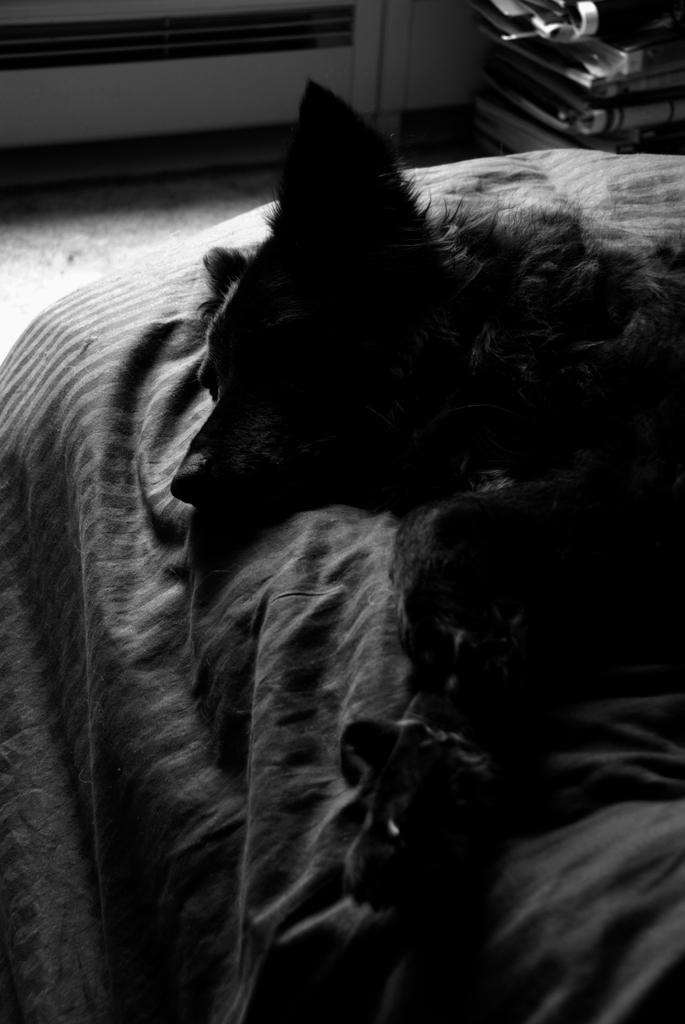What type of animal is present in the image? There is a dog in the image. Where is the dog located? The dog is lying on the bed. What is located beside the dog? There is a blanket beside the dog. What can be seen in the top right corner of the image? There are books and files in the wooden track in the top right corner of the image. What type of playground equipment can be seen in the image? There is no playground equipment present in the image. What is the dog's opinion on the books and files in the wooden track? The image does not provide any information about the dog's opinion on the books and files. 